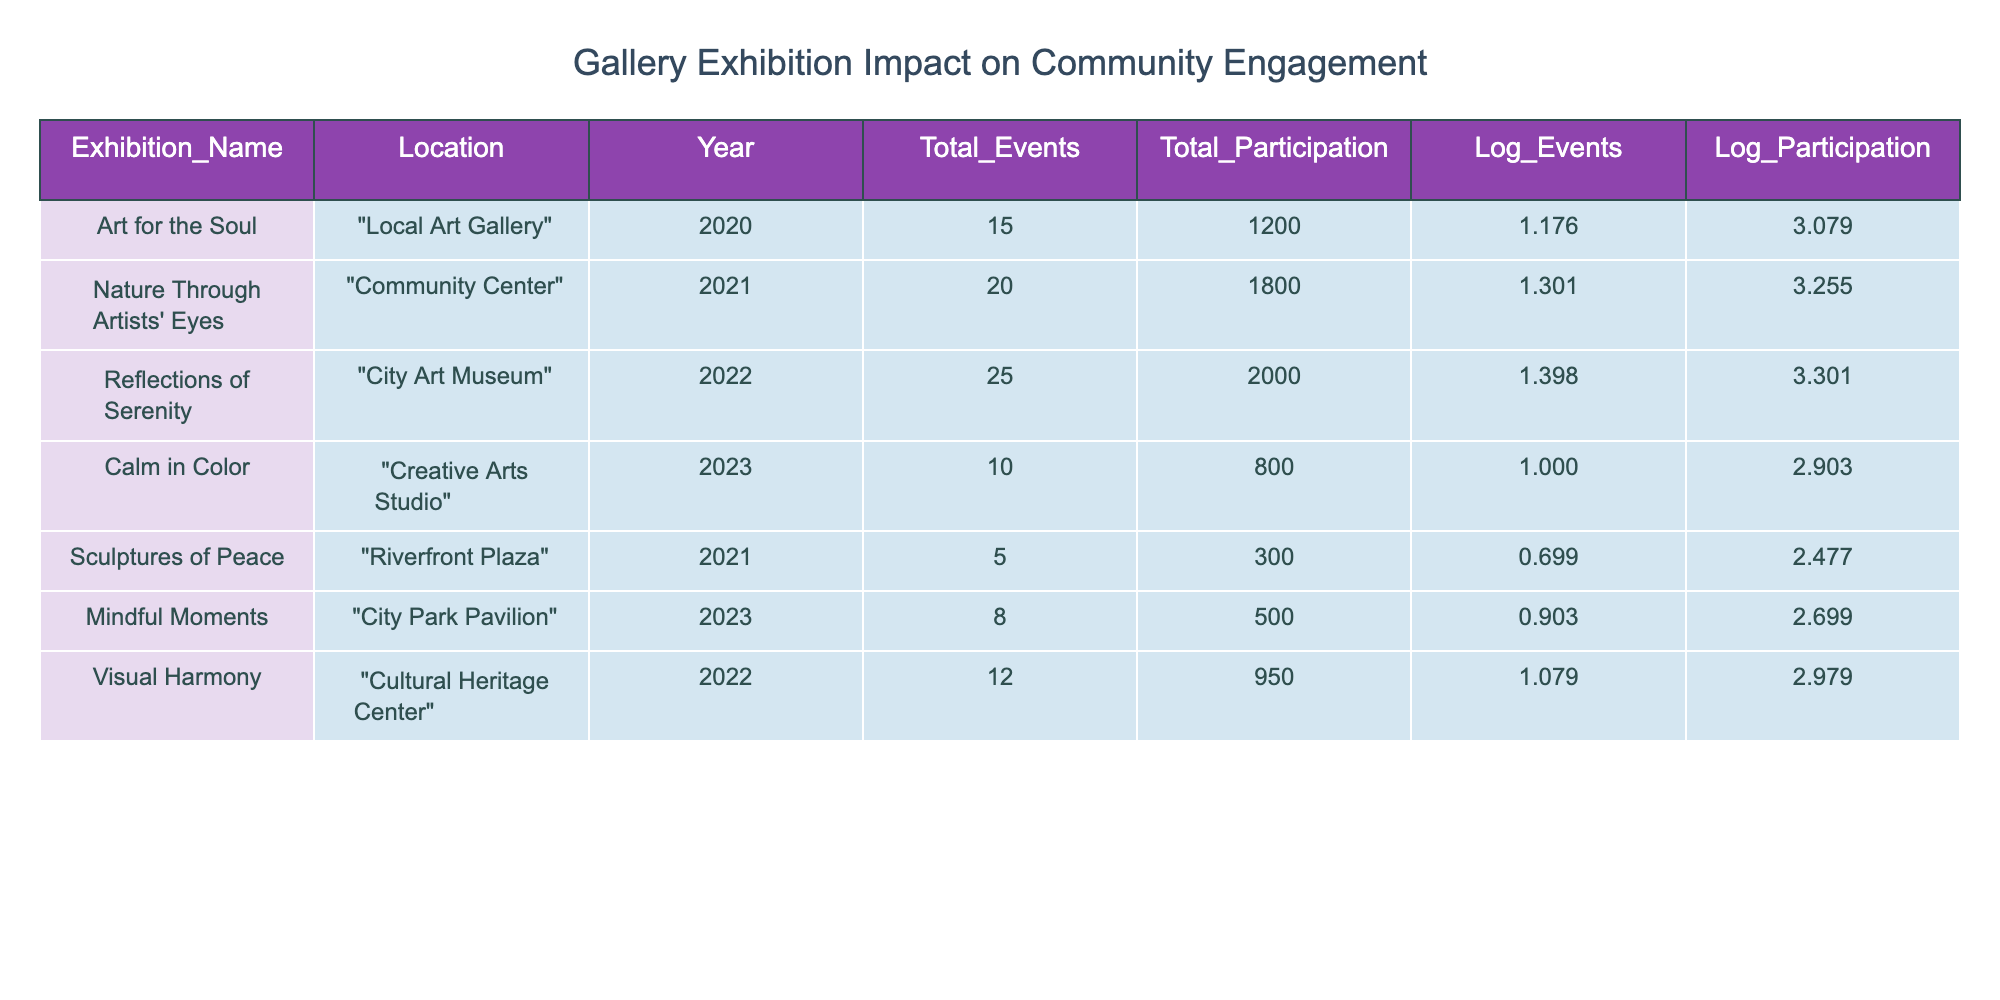What was the total participation in "Mindful Moments"? The table lists "Mindful Moments" under the exhibition name, and the corresponding value in the "Total_Participation" column is 500.
Answer: 500 Which exhibition had the highest number of total events? By comparing the values in the "Total_Events" column, "Reflections of Serenity" has the highest total events, with a value of 25.
Answer: Reflections of Serenity What is the log value for total events in "Calm in Color"? The log value for total events is listed under the "Log_Events" column for "Calm in Color" which is 1.000000.
Answer: 1.000000 Is the total participation in "Sculptures of Peace" greater than 500? The total participation for "Sculptures of Peace" is 300, which is less than 500.
Answer: No What is the average total events for exhibitions held in 2023? First, identify the exhibitions held in 2023: "Calm in Color" (10 events) and "Mindful Moments" (8 events). Then, sum the total events: 10 + 8 = 18. Finally, divide by the number of exhibitions (2): 18 / 2 = 9.
Answer: 9 Which exhibition has the lowest log value of participation? By looking at the "Log_Participation" column, "Calm in Color" has the lowest log value of participation which is 2.903090.
Answer: Calm in Color How many total events were held at the "Local Art Gallery"? The exhibition "Art for the Soul" is held at the "Local Art Gallery" and it has a total of 15 events listed.
Answer: 15 What is the total participation across all exhibitions held in 2021? Identify the events in 2021: "Nature Through Artists' Eyes" with 1800 participation and "Sculptures of Peace" with 300 participation. Add them together: 1800 + 300 = 2100.
Answer: 2100 Did "Visual Harmony" have a higher log participation than "Art for the Soul"? The log participation for "Visual Harmony" is 2.978810 while "Art for the Soul" has a log participation of 3.079181. Since 2.978810 is less than 3.079181, the answer is no.
Answer: No 